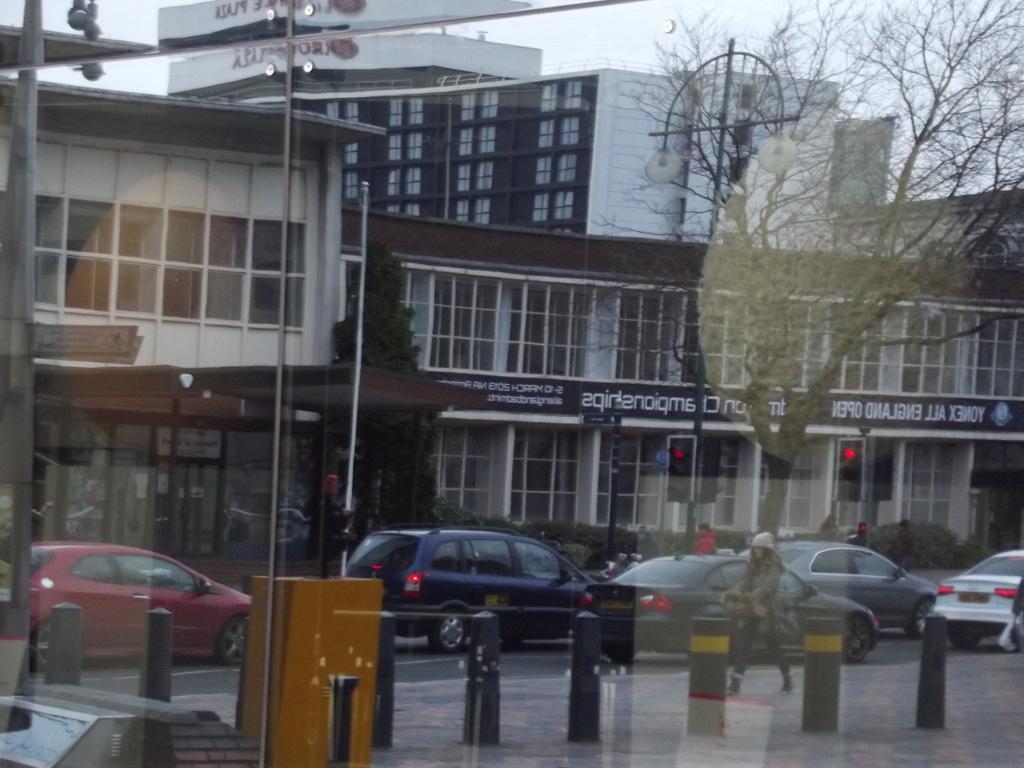In one or two sentences, can you explain what this image depicts? There is a glass. A person is walking on the road. There are vehicles. At the back there are buildings, trees and poles. 